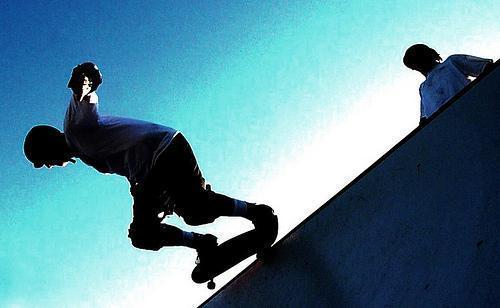How many people are there?
Give a very brief answer. 2. 